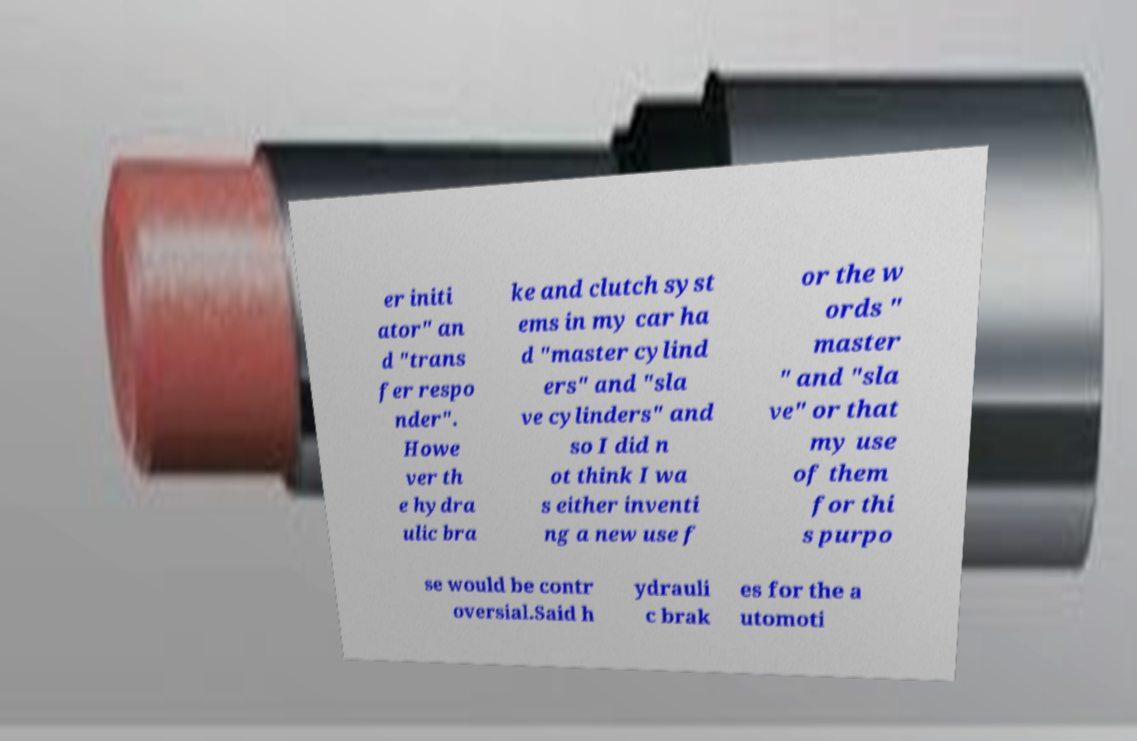For documentation purposes, I need the text within this image transcribed. Could you provide that? er initi ator" an d "trans fer respo nder". Howe ver th e hydra ulic bra ke and clutch syst ems in my car ha d "master cylind ers" and "sla ve cylinders" and so I did n ot think I wa s either inventi ng a new use f or the w ords " master " and "sla ve" or that my use of them for thi s purpo se would be contr oversial.Said h ydrauli c brak es for the a utomoti 